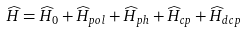Convert formula to latex. <formula><loc_0><loc_0><loc_500><loc_500>\widehat { H } = \widehat { H } _ { 0 } + \widehat { H } _ { p o l } + \widehat { H } _ { p h } + \widehat { H } _ { c p } + \widehat { H } _ { d c p }</formula> 